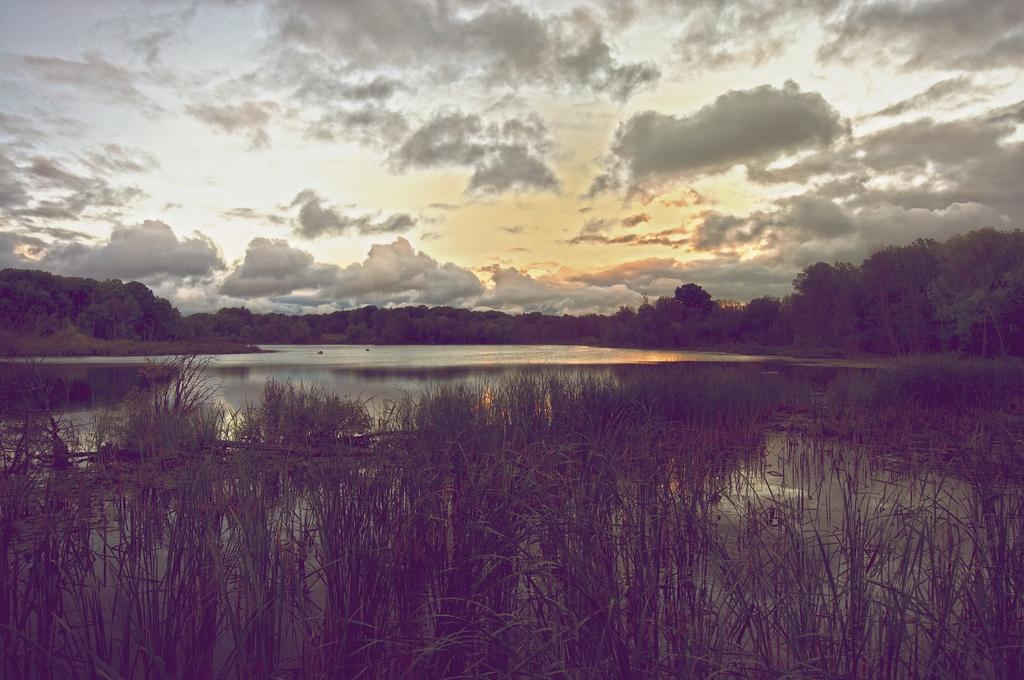What type of vegetation can be seen in the image? There are trees in the image. What natural element is also visible in the image? There is water visible in the image. What type of ground cover is present in the image? There is grass in the image. What is the color of the sky in the image? The sky is white in color. How many friends are sitting on the beds in the image? There are no friends or beds present in the image. What color is the orange in the image? There is no orange present in the image. 